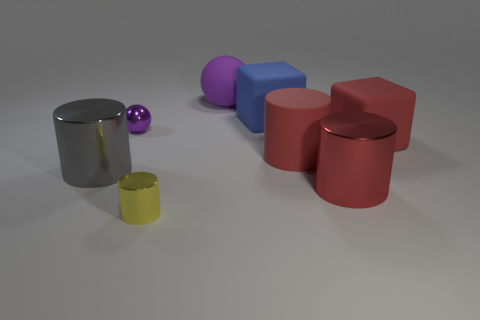Add 2 large rubber balls. How many objects exist? 10 Subtract all red matte cylinders. How many cylinders are left? 3 Subtract 1 spheres. How many spheres are left? 1 Subtract all blocks. How many objects are left? 6 Subtract all blue blocks. How many blocks are left? 1 Subtract all cyan blocks. Subtract all brown cylinders. How many blocks are left? 2 Subtract all small yellow shiny things. Subtract all large metal cylinders. How many objects are left? 5 Add 6 matte spheres. How many matte spheres are left? 7 Add 6 small cyan matte cylinders. How many small cyan matte cylinders exist? 6 Subtract 0 gray cubes. How many objects are left? 8 